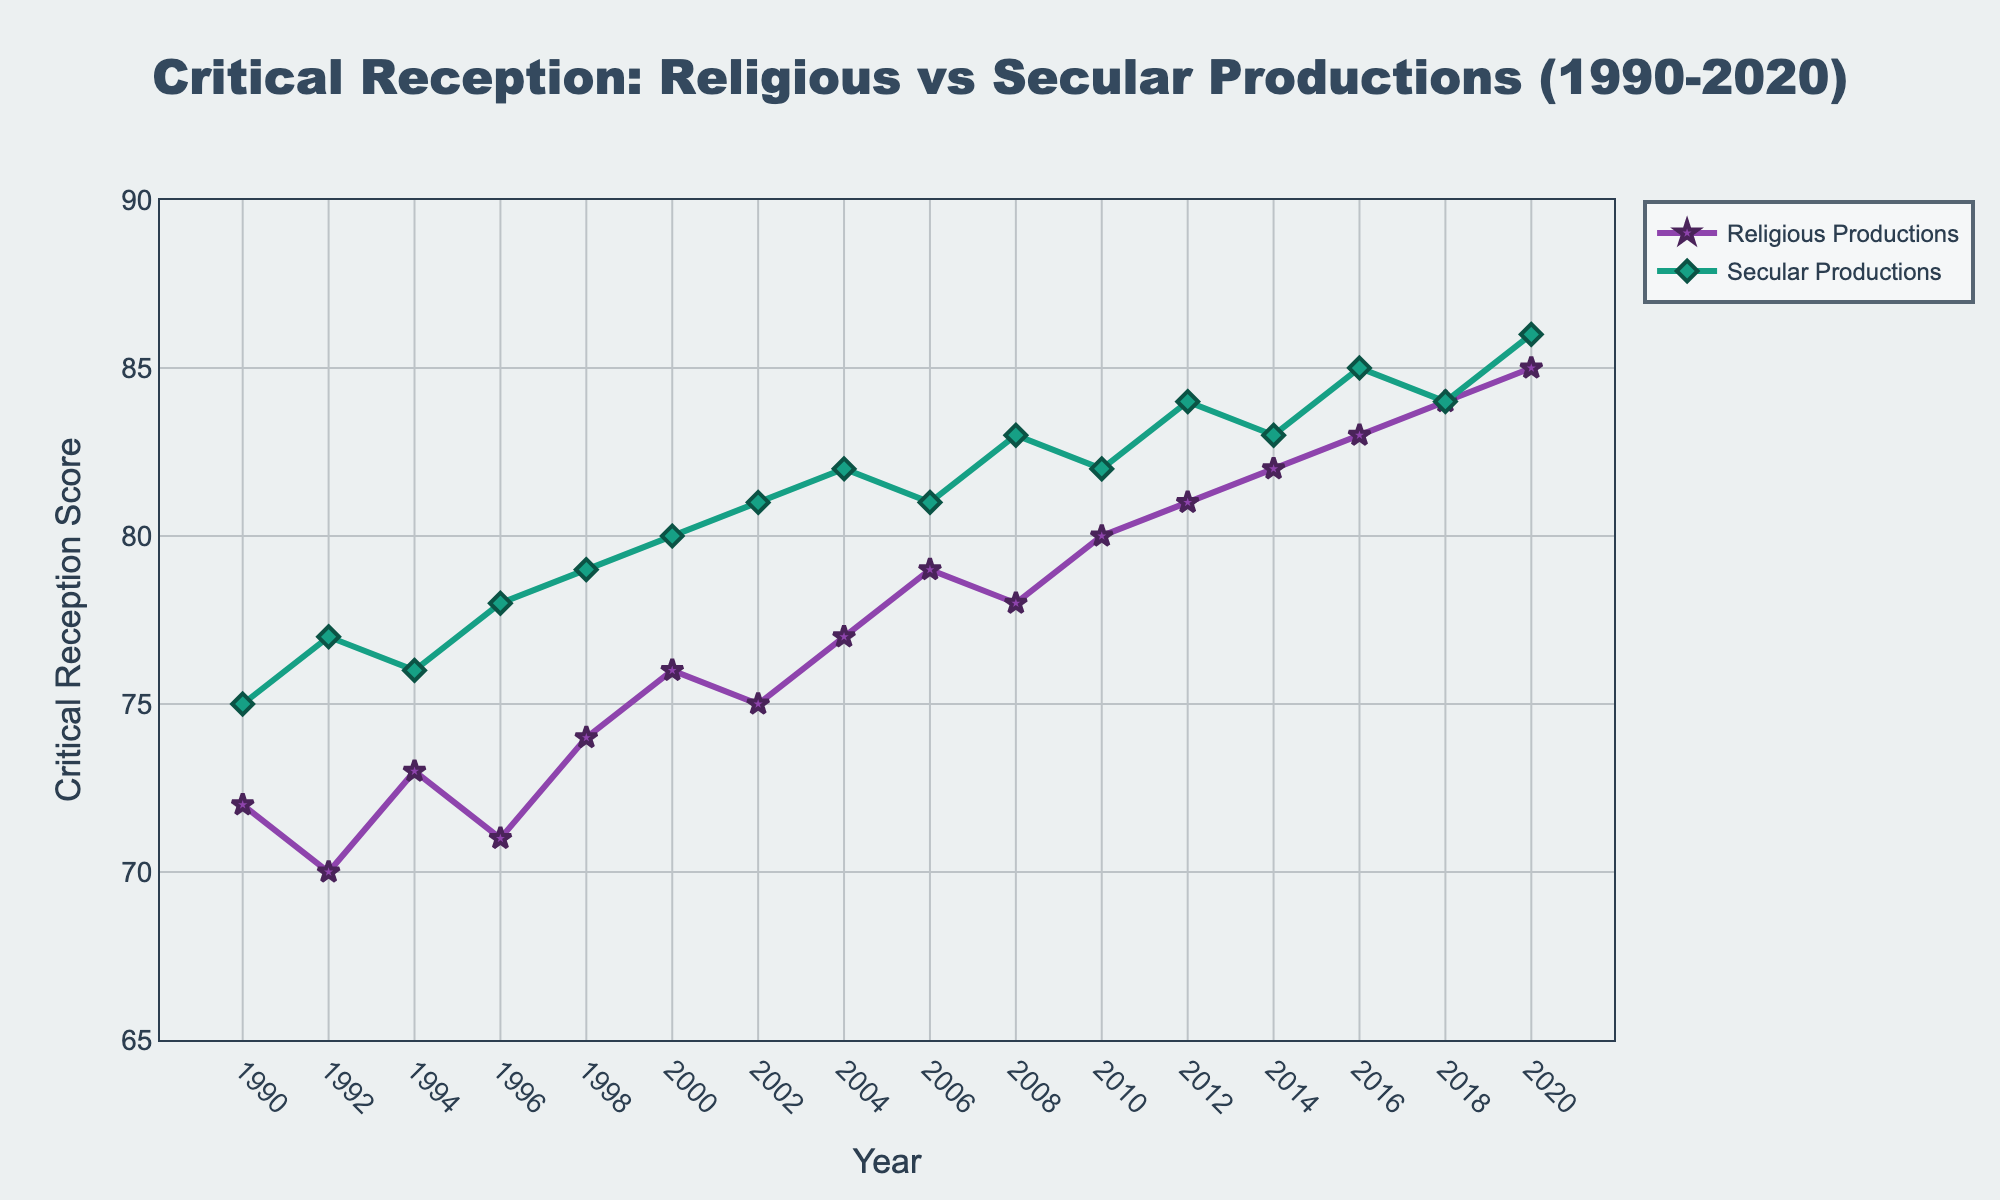When did Religious Productions first surpass a score of 80? In the line chart, locate the years on the x-axis and track the trend for Religious Productions. Look for the first instance where the score exceeds 80.
Answer: 2010 In which year do both Religious and Secular Productions have the same score? Observe the line chart where the two lines intersect or match on the y-axis. The score of both should be equal in that year.
Answer: 2018 How many years did it take for Religious Productions to increase from 75 to 85? Identify the years when the score for Religious Productions was 75 and when it reached 85. Calculate the difference between these two years.
Answer: 18 years Which production type has a greater increase in score from 2000 to 2020? Subtract the 2000 score from the 2020 score for both Religious and Secular Productions. Compare the differences to see which is greater. Religious Productions: 85 - 76 = 9 Secular Productions: 86 - 80 = 6
Answer: Religious Productions What is the average score for Secular Productions across the entire period shown? Sum the scores of Secular Productions from 1990 to 2020 and then divide by the number of data points (16 years). Sum = 75 + 77 + 76 + 78 + 79 + 80 + 81 + 82 + 81 + 83 + 82 + 84 + 83 + 85 + 84 + 86 = 1206 Average = 1206 / 16
Answer: 75.375 